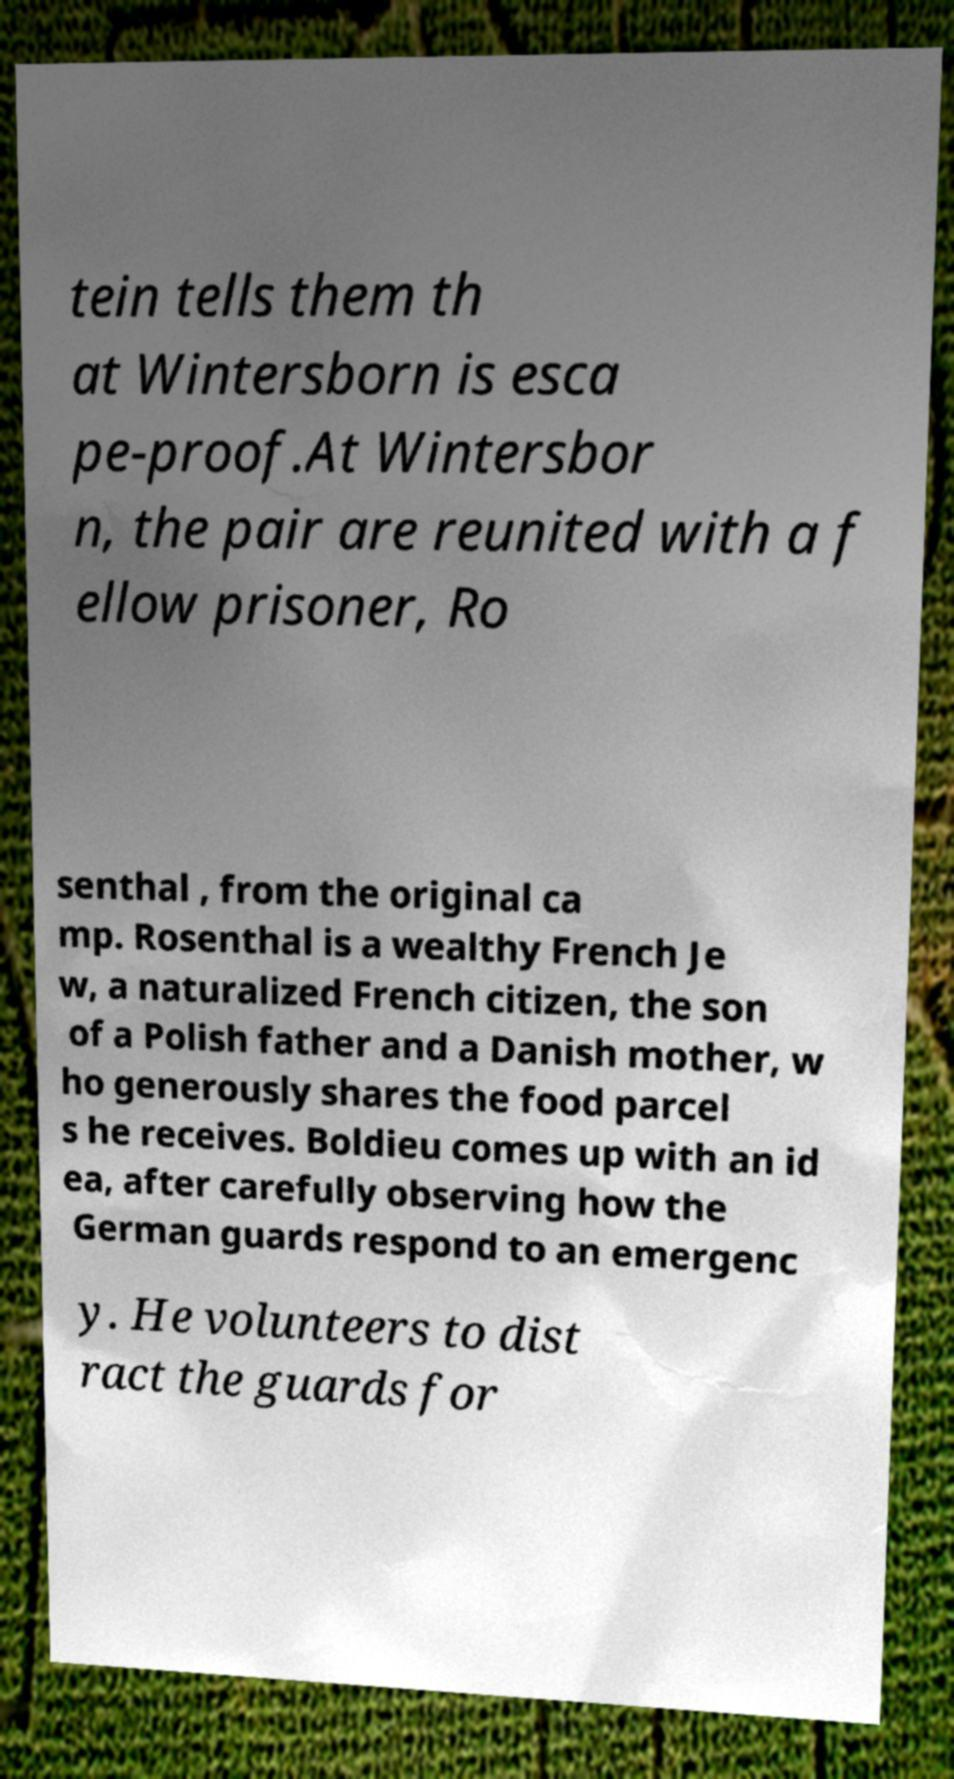I need the written content from this picture converted into text. Can you do that? tein tells them th at Wintersborn is esca pe-proof.At Wintersbor n, the pair are reunited with a f ellow prisoner, Ro senthal , from the original ca mp. Rosenthal is a wealthy French Je w, a naturalized French citizen, the son of a Polish father and a Danish mother, w ho generously shares the food parcel s he receives. Boldieu comes up with an id ea, after carefully observing how the German guards respond to an emergenc y. He volunteers to dist ract the guards for 